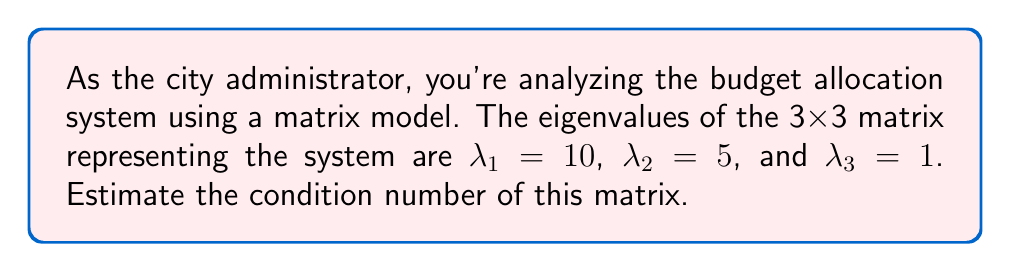Show me your answer to this math problem. To estimate the condition number of a matrix, we'll follow these steps:

1) The condition number $\kappa(A)$ for a matrix $A$ is defined as:

   $$\kappa(A) = \|A\| \cdot \|A^{-1}\|$$

2) For a symmetric matrix, the condition number can be calculated using the largest and smallest eigenvalues:

   $$\kappa(A) = \frac{|\lambda_{max}|}{|\lambda_{min}|}$$

   where $\lambda_{max}$ is the eigenvalue with the largest absolute value and $\lambda_{min}$ is the eigenvalue with the smallest absolute value.

3) In this case:
   $\lambda_{max} = 10$
   $\lambda_{min} = 1$

4) Substituting these values into the formula:

   $$\kappa(A) = \frac{|10|}{|1|} = 10$$

5) Therefore, the estimated condition number of the matrix is 10.

This condition number suggests that the budget allocation system is moderately well-conditioned. A condition number close to 1 indicates a well-conditioned matrix, while much larger values indicate ill-conditioning.
Answer: 10 